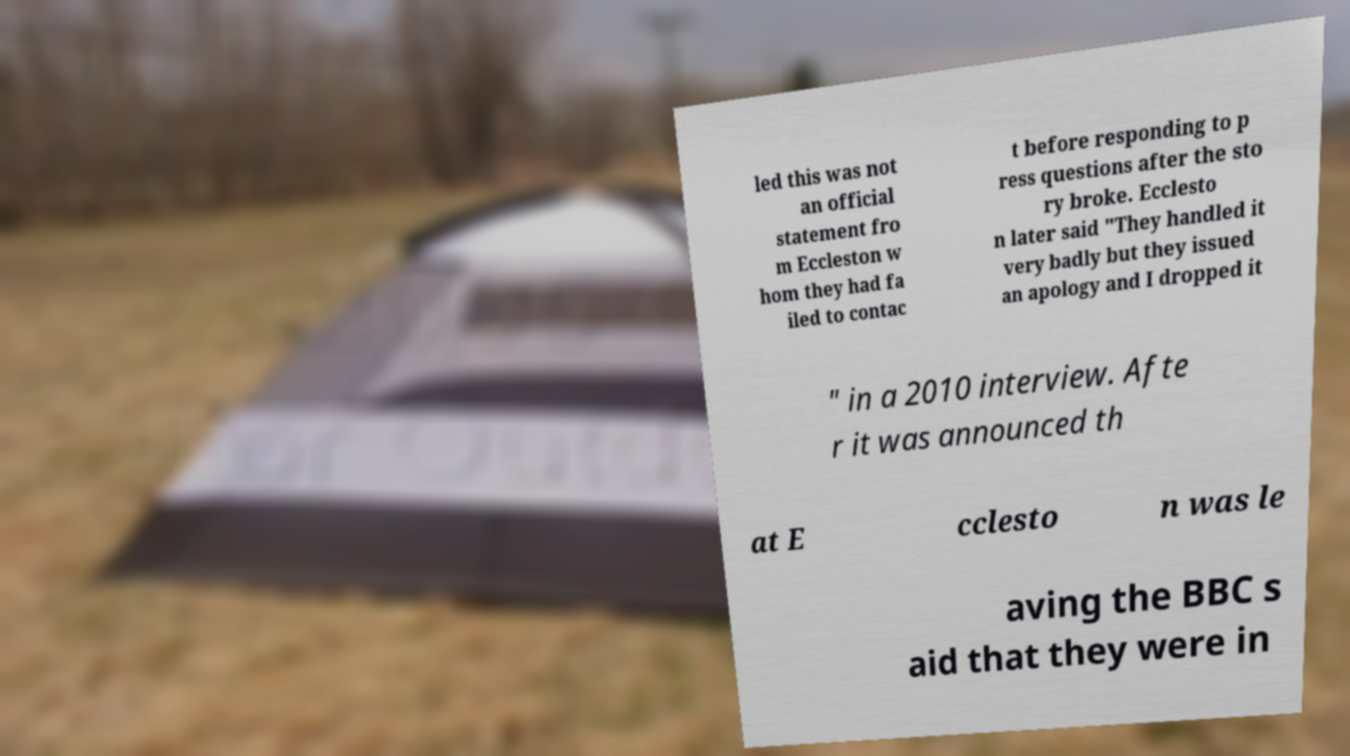Please identify and transcribe the text found in this image. led this was not an official statement fro m Eccleston w hom they had fa iled to contac t before responding to p ress questions after the sto ry broke. Ecclesto n later said "They handled it very badly but they issued an apology and I dropped it " in a 2010 interview. Afte r it was announced th at E cclesto n was le aving the BBC s aid that they were in 